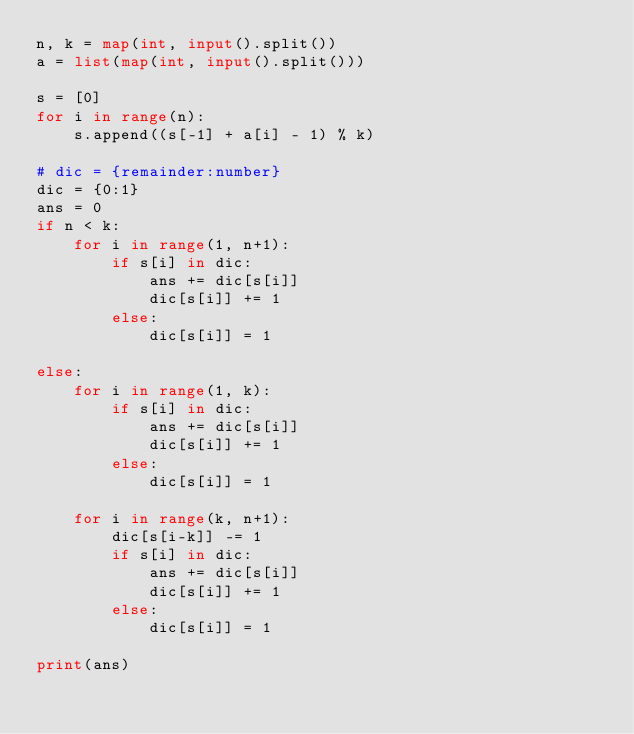<code> <loc_0><loc_0><loc_500><loc_500><_Python_>n, k = map(int, input().split())
a = list(map(int, input().split()))

s = [0]
for i in range(n):
    s.append((s[-1] + a[i] - 1) % k)

# dic = {remainder:number}
dic = {0:1}
ans = 0
if n < k:
    for i in range(1, n+1):
        if s[i] in dic:
            ans += dic[s[i]]
            dic[s[i]] += 1
        else:
            dic[s[i]] = 1

else:
    for i in range(1, k):
        if s[i] in dic:
            ans += dic[s[i]]
            dic[s[i]] += 1
        else:
            dic[s[i]] = 1

    for i in range(k, n+1):
        dic[s[i-k]] -= 1
        if s[i] in dic:
            ans += dic[s[i]]
            dic[s[i]] += 1
        else:
            dic[s[i]] = 1

print(ans)</code> 